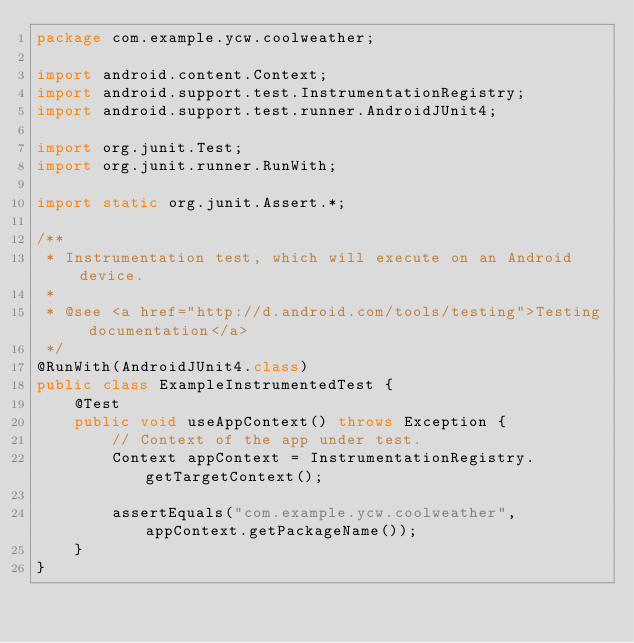Convert code to text. <code><loc_0><loc_0><loc_500><loc_500><_Java_>package com.example.ycw.coolweather;

import android.content.Context;
import android.support.test.InstrumentationRegistry;
import android.support.test.runner.AndroidJUnit4;

import org.junit.Test;
import org.junit.runner.RunWith;

import static org.junit.Assert.*;

/**
 * Instrumentation test, which will execute on an Android device.
 *
 * @see <a href="http://d.android.com/tools/testing">Testing documentation</a>
 */
@RunWith(AndroidJUnit4.class)
public class ExampleInstrumentedTest {
    @Test
    public void useAppContext() throws Exception {
        // Context of the app under test.
        Context appContext = InstrumentationRegistry.getTargetContext();

        assertEquals("com.example.ycw.coolweather", appContext.getPackageName());
    }
}
</code> 